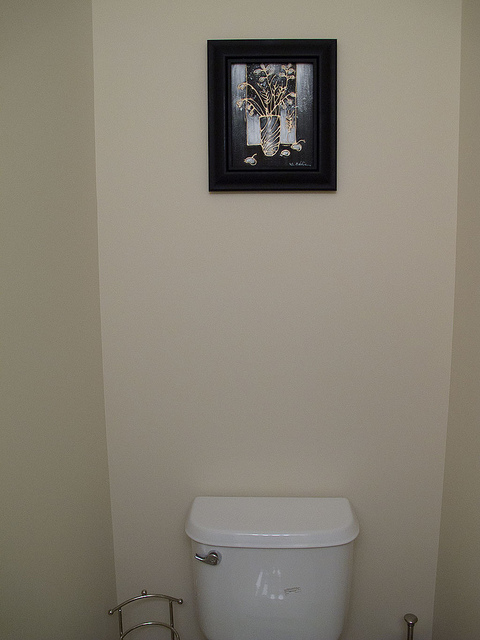How many pictures are on the wall? There is one picture on the wall above the toilet. It is framed, featuring what appears to be a still-life image with a vase and flowers. 